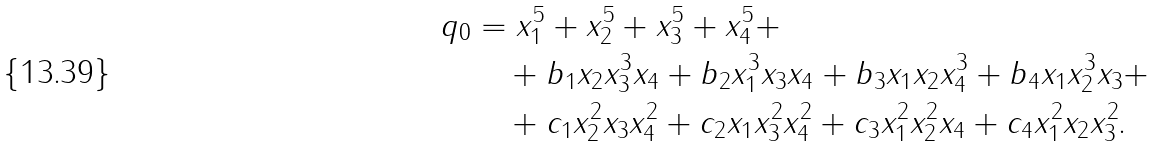<formula> <loc_0><loc_0><loc_500><loc_500>q _ { 0 } & = x _ { 1 } ^ { 5 } + x _ { 2 } ^ { 5 } + x _ { 3 } ^ { 5 } + x _ { 4 } ^ { 5 } + \\ & \quad + b _ { 1 } x _ { 2 } x _ { 3 } ^ { 3 } x _ { 4 } + b _ { 2 } x _ { 1 } ^ { 3 } x _ { 3 } x _ { 4 } + b _ { 3 } x _ { 1 } x _ { 2 } x _ { 4 } ^ { 3 } + b _ { 4 } x _ { 1 } x _ { 2 } ^ { 3 } x _ { 3 } + \\ & \quad + c _ { 1 } x _ { 2 } ^ { 2 } x _ { 3 } x _ { 4 } ^ { 2 } + c _ { 2 } x _ { 1 } x _ { 3 } ^ { 2 } x _ { 4 } ^ { 2 } + c _ { 3 } x _ { 1 } ^ { 2 } x _ { 2 } ^ { 2 } x _ { 4 } + c _ { 4 } x _ { 1 } ^ { 2 } x _ { 2 } x _ { 3 } ^ { 2 } \text {.}</formula> 